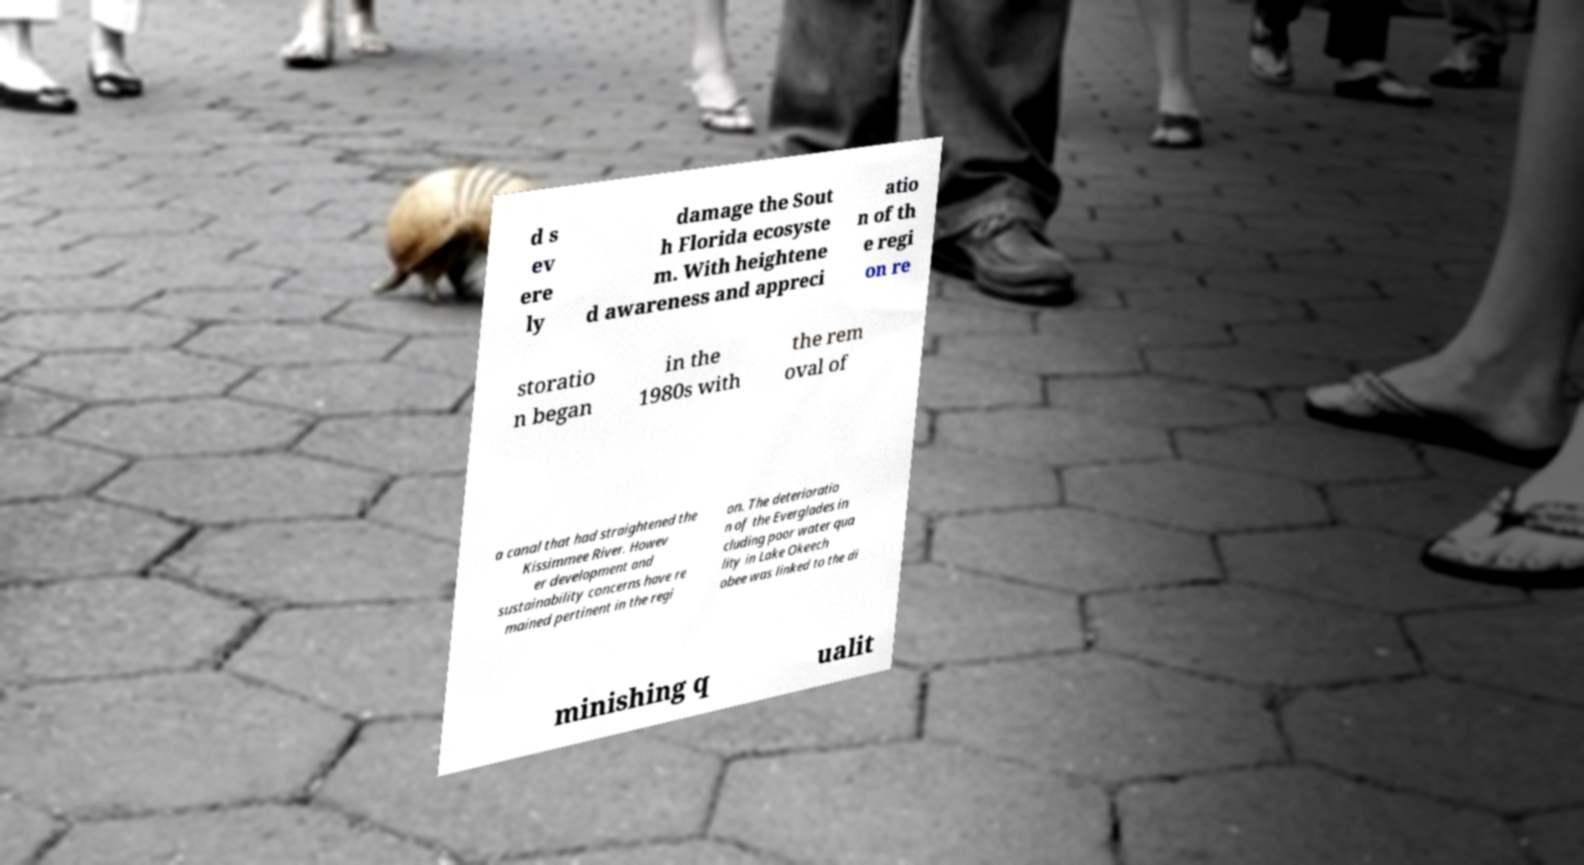Please identify and transcribe the text found in this image. d s ev ere ly damage the Sout h Florida ecosyste m. With heightene d awareness and appreci atio n of th e regi on re storatio n began in the 1980s with the rem oval of a canal that had straightened the Kissimmee River. Howev er development and sustainability concerns have re mained pertinent in the regi on. The deterioratio n of the Everglades in cluding poor water qua lity in Lake Okeech obee was linked to the di minishing q ualit 